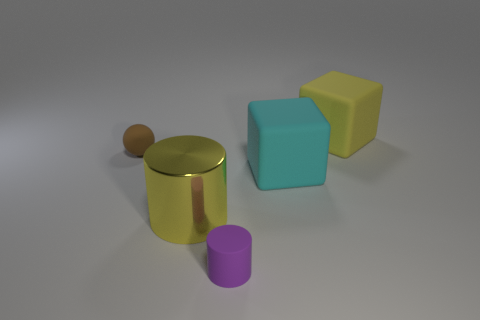Add 3 tiny brown rubber things. How many objects exist? 8 Subtract all yellow cubes. How many cubes are left? 1 Subtract 1 cubes. How many cubes are left? 1 Subtract all cyan objects. Subtract all purple rubber cylinders. How many objects are left? 3 Add 4 large cyan matte objects. How many large cyan matte objects are left? 5 Add 1 large green metallic cubes. How many large green metallic cubes exist? 1 Subtract 0 yellow spheres. How many objects are left? 5 Subtract all cylinders. How many objects are left? 3 Subtract all gray spheres. Subtract all yellow cylinders. How many spheres are left? 1 